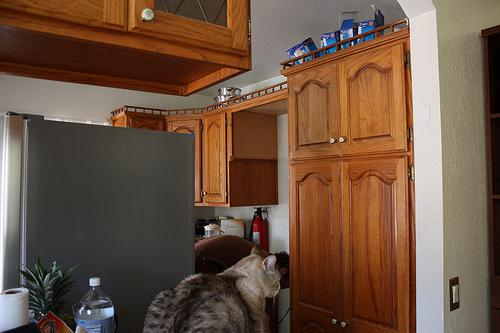Question: where is the cat?
Choices:
A. In the window.
B. On a fence.
C. In a tree.
D. On the counter.
Answer with the letter. Answer: D Question: what material are the cabinets?
Choices:
A. Plastic.
B. Glass.
C. Stone.
D. Wood.
Answer with the letter. Answer: D Question: where is the pineapple?
Choices:
A. Left of cat.
B. In the tree.
C. At the grocery store.
D. In the kitchen.
Answer with the letter. Answer: A Question: where are the open blue boxes?
Choices:
A. Atop the cabinet.
B. The garage.
C. The kitchen.
D. The garbage.
Answer with the letter. Answer: A Question: how many people are visible?
Choices:
A. One.
B. Two.
C. Zero.
D. Three.
Answer with the letter. Answer: C 